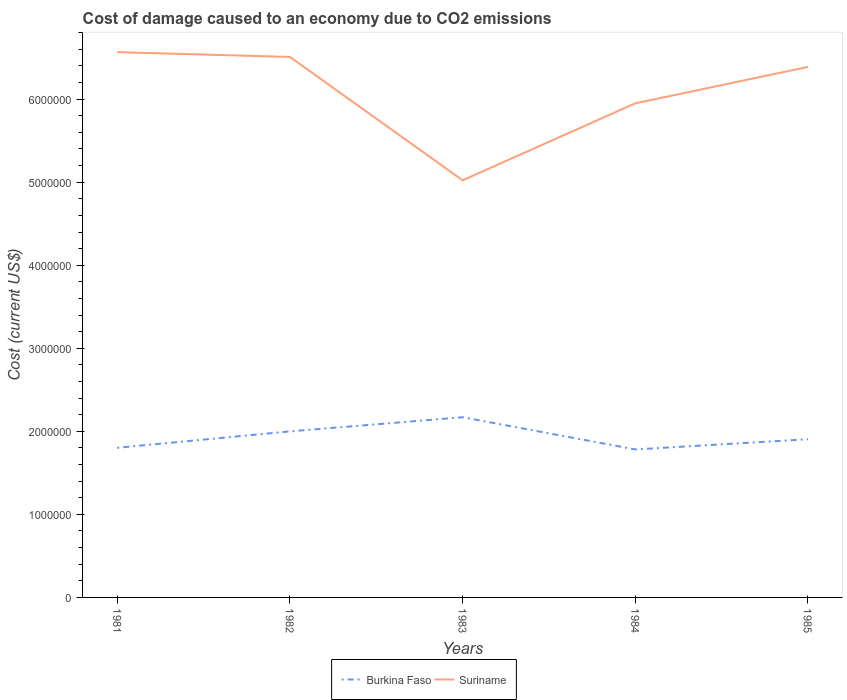How many different coloured lines are there?
Provide a short and direct response. 2. Does the line corresponding to Suriname intersect with the line corresponding to Burkina Faso?
Provide a succinct answer. No. Is the number of lines equal to the number of legend labels?
Keep it short and to the point. Yes. Across all years, what is the maximum cost of damage caused due to CO2 emissisons in Burkina Faso?
Provide a short and direct response. 1.78e+06. What is the total cost of damage caused due to CO2 emissisons in Burkina Faso in the graph?
Keep it short and to the point. -3.68e+05. What is the difference between the highest and the second highest cost of damage caused due to CO2 emissisons in Burkina Faso?
Make the answer very short. 3.88e+05. What is the difference between the highest and the lowest cost of damage caused due to CO2 emissisons in Burkina Faso?
Give a very brief answer. 2. Is the cost of damage caused due to CO2 emissisons in Suriname strictly greater than the cost of damage caused due to CO2 emissisons in Burkina Faso over the years?
Keep it short and to the point. No. How many lines are there?
Make the answer very short. 2. Are the values on the major ticks of Y-axis written in scientific E-notation?
Offer a very short reply. No. Does the graph contain any zero values?
Your answer should be very brief. No. Where does the legend appear in the graph?
Give a very brief answer. Bottom center. How many legend labels are there?
Provide a succinct answer. 2. What is the title of the graph?
Ensure brevity in your answer.  Cost of damage caused to an economy due to CO2 emissions. Does "European Union" appear as one of the legend labels in the graph?
Your answer should be compact. No. What is the label or title of the X-axis?
Make the answer very short. Years. What is the label or title of the Y-axis?
Provide a short and direct response. Cost (current US$). What is the Cost (current US$) of Burkina Faso in 1981?
Make the answer very short. 1.80e+06. What is the Cost (current US$) in Suriname in 1981?
Your response must be concise. 6.57e+06. What is the Cost (current US$) of Burkina Faso in 1982?
Your answer should be compact. 2.00e+06. What is the Cost (current US$) of Suriname in 1982?
Your answer should be compact. 6.51e+06. What is the Cost (current US$) of Burkina Faso in 1983?
Offer a terse response. 2.17e+06. What is the Cost (current US$) in Suriname in 1983?
Your answer should be very brief. 5.02e+06. What is the Cost (current US$) of Burkina Faso in 1984?
Make the answer very short. 1.78e+06. What is the Cost (current US$) of Suriname in 1984?
Provide a short and direct response. 5.95e+06. What is the Cost (current US$) in Burkina Faso in 1985?
Your response must be concise. 1.90e+06. What is the Cost (current US$) in Suriname in 1985?
Make the answer very short. 6.39e+06. Across all years, what is the maximum Cost (current US$) in Burkina Faso?
Your response must be concise. 2.17e+06. Across all years, what is the maximum Cost (current US$) of Suriname?
Offer a very short reply. 6.57e+06. Across all years, what is the minimum Cost (current US$) of Burkina Faso?
Give a very brief answer. 1.78e+06. Across all years, what is the minimum Cost (current US$) of Suriname?
Provide a succinct answer. 5.02e+06. What is the total Cost (current US$) of Burkina Faso in the graph?
Ensure brevity in your answer.  9.66e+06. What is the total Cost (current US$) in Suriname in the graph?
Your answer should be very brief. 3.04e+07. What is the difference between the Cost (current US$) in Burkina Faso in 1981 and that in 1982?
Give a very brief answer. -1.98e+05. What is the difference between the Cost (current US$) in Suriname in 1981 and that in 1982?
Make the answer very short. 5.83e+04. What is the difference between the Cost (current US$) in Burkina Faso in 1981 and that in 1983?
Offer a terse response. -3.68e+05. What is the difference between the Cost (current US$) in Suriname in 1981 and that in 1983?
Your answer should be compact. 1.54e+06. What is the difference between the Cost (current US$) in Burkina Faso in 1981 and that in 1984?
Keep it short and to the point. 1.95e+04. What is the difference between the Cost (current US$) of Suriname in 1981 and that in 1984?
Your response must be concise. 6.17e+05. What is the difference between the Cost (current US$) of Burkina Faso in 1981 and that in 1985?
Your answer should be very brief. -1.03e+05. What is the difference between the Cost (current US$) in Suriname in 1981 and that in 1985?
Your answer should be very brief. 1.78e+05. What is the difference between the Cost (current US$) in Burkina Faso in 1982 and that in 1983?
Your answer should be very brief. -1.70e+05. What is the difference between the Cost (current US$) in Suriname in 1982 and that in 1983?
Offer a very short reply. 1.49e+06. What is the difference between the Cost (current US$) of Burkina Faso in 1982 and that in 1984?
Your answer should be compact. 2.17e+05. What is the difference between the Cost (current US$) of Suriname in 1982 and that in 1984?
Your answer should be compact. 5.58e+05. What is the difference between the Cost (current US$) in Burkina Faso in 1982 and that in 1985?
Provide a short and direct response. 9.48e+04. What is the difference between the Cost (current US$) of Suriname in 1982 and that in 1985?
Offer a terse response. 1.20e+05. What is the difference between the Cost (current US$) of Burkina Faso in 1983 and that in 1984?
Offer a terse response. 3.88e+05. What is the difference between the Cost (current US$) in Suriname in 1983 and that in 1984?
Keep it short and to the point. -9.27e+05. What is the difference between the Cost (current US$) in Burkina Faso in 1983 and that in 1985?
Give a very brief answer. 2.65e+05. What is the difference between the Cost (current US$) in Suriname in 1983 and that in 1985?
Your response must be concise. -1.37e+06. What is the difference between the Cost (current US$) of Burkina Faso in 1984 and that in 1985?
Your response must be concise. -1.23e+05. What is the difference between the Cost (current US$) in Suriname in 1984 and that in 1985?
Offer a very short reply. -4.38e+05. What is the difference between the Cost (current US$) in Burkina Faso in 1981 and the Cost (current US$) in Suriname in 1982?
Make the answer very short. -4.71e+06. What is the difference between the Cost (current US$) of Burkina Faso in 1981 and the Cost (current US$) of Suriname in 1983?
Offer a terse response. -3.22e+06. What is the difference between the Cost (current US$) of Burkina Faso in 1981 and the Cost (current US$) of Suriname in 1984?
Offer a terse response. -4.15e+06. What is the difference between the Cost (current US$) of Burkina Faso in 1981 and the Cost (current US$) of Suriname in 1985?
Your answer should be compact. -4.59e+06. What is the difference between the Cost (current US$) in Burkina Faso in 1982 and the Cost (current US$) in Suriname in 1983?
Ensure brevity in your answer.  -3.02e+06. What is the difference between the Cost (current US$) in Burkina Faso in 1982 and the Cost (current US$) in Suriname in 1984?
Give a very brief answer. -3.95e+06. What is the difference between the Cost (current US$) of Burkina Faso in 1982 and the Cost (current US$) of Suriname in 1985?
Your answer should be compact. -4.39e+06. What is the difference between the Cost (current US$) in Burkina Faso in 1983 and the Cost (current US$) in Suriname in 1984?
Ensure brevity in your answer.  -3.78e+06. What is the difference between the Cost (current US$) of Burkina Faso in 1983 and the Cost (current US$) of Suriname in 1985?
Make the answer very short. -4.22e+06. What is the difference between the Cost (current US$) in Burkina Faso in 1984 and the Cost (current US$) in Suriname in 1985?
Keep it short and to the point. -4.61e+06. What is the average Cost (current US$) of Burkina Faso per year?
Keep it short and to the point. 1.93e+06. What is the average Cost (current US$) in Suriname per year?
Offer a very short reply. 6.09e+06. In the year 1981, what is the difference between the Cost (current US$) in Burkina Faso and Cost (current US$) in Suriname?
Provide a short and direct response. -4.76e+06. In the year 1982, what is the difference between the Cost (current US$) of Burkina Faso and Cost (current US$) of Suriname?
Provide a short and direct response. -4.51e+06. In the year 1983, what is the difference between the Cost (current US$) of Burkina Faso and Cost (current US$) of Suriname?
Provide a succinct answer. -2.85e+06. In the year 1984, what is the difference between the Cost (current US$) in Burkina Faso and Cost (current US$) in Suriname?
Make the answer very short. -4.17e+06. In the year 1985, what is the difference between the Cost (current US$) of Burkina Faso and Cost (current US$) of Suriname?
Your answer should be very brief. -4.48e+06. What is the ratio of the Cost (current US$) of Burkina Faso in 1981 to that in 1982?
Provide a succinct answer. 0.9. What is the ratio of the Cost (current US$) of Burkina Faso in 1981 to that in 1983?
Provide a short and direct response. 0.83. What is the ratio of the Cost (current US$) in Suriname in 1981 to that in 1983?
Your answer should be very brief. 1.31. What is the ratio of the Cost (current US$) in Burkina Faso in 1981 to that in 1984?
Offer a terse response. 1.01. What is the ratio of the Cost (current US$) of Suriname in 1981 to that in 1984?
Provide a short and direct response. 1.1. What is the ratio of the Cost (current US$) of Burkina Faso in 1981 to that in 1985?
Provide a short and direct response. 0.95. What is the ratio of the Cost (current US$) in Suriname in 1981 to that in 1985?
Make the answer very short. 1.03. What is the ratio of the Cost (current US$) in Burkina Faso in 1982 to that in 1983?
Ensure brevity in your answer.  0.92. What is the ratio of the Cost (current US$) of Suriname in 1982 to that in 1983?
Ensure brevity in your answer.  1.3. What is the ratio of the Cost (current US$) in Burkina Faso in 1982 to that in 1984?
Give a very brief answer. 1.12. What is the ratio of the Cost (current US$) in Suriname in 1982 to that in 1984?
Offer a terse response. 1.09. What is the ratio of the Cost (current US$) of Burkina Faso in 1982 to that in 1985?
Give a very brief answer. 1.05. What is the ratio of the Cost (current US$) of Suriname in 1982 to that in 1985?
Make the answer very short. 1.02. What is the ratio of the Cost (current US$) of Burkina Faso in 1983 to that in 1984?
Offer a very short reply. 1.22. What is the ratio of the Cost (current US$) in Suriname in 1983 to that in 1984?
Your answer should be compact. 0.84. What is the ratio of the Cost (current US$) of Burkina Faso in 1983 to that in 1985?
Offer a very short reply. 1.14. What is the ratio of the Cost (current US$) of Suriname in 1983 to that in 1985?
Offer a very short reply. 0.79. What is the ratio of the Cost (current US$) of Burkina Faso in 1984 to that in 1985?
Provide a succinct answer. 0.94. What is the ratio of the Cost (current US$) in Suriname in 1984 to that in 1985?
Make the answer very short. 0.93. What is the difference between the highest and the second highest Cost (current US$) of Burkina Faso?
Offer a terse response. 1.70e+05. What is the difference between the highest and the second highest Cost (current US$) of Suriname?
Ensure brevity in your answer.  5.83e+04. What is the difference between the highest and the lowest Cost (current US$) in Burkina Faso?
Keep it short and to the point. 3.88e+05. What is the difference between the highest and the lowest Cost (current US$) in Suriname?
Your answer should be compact. 1.54e+06. 